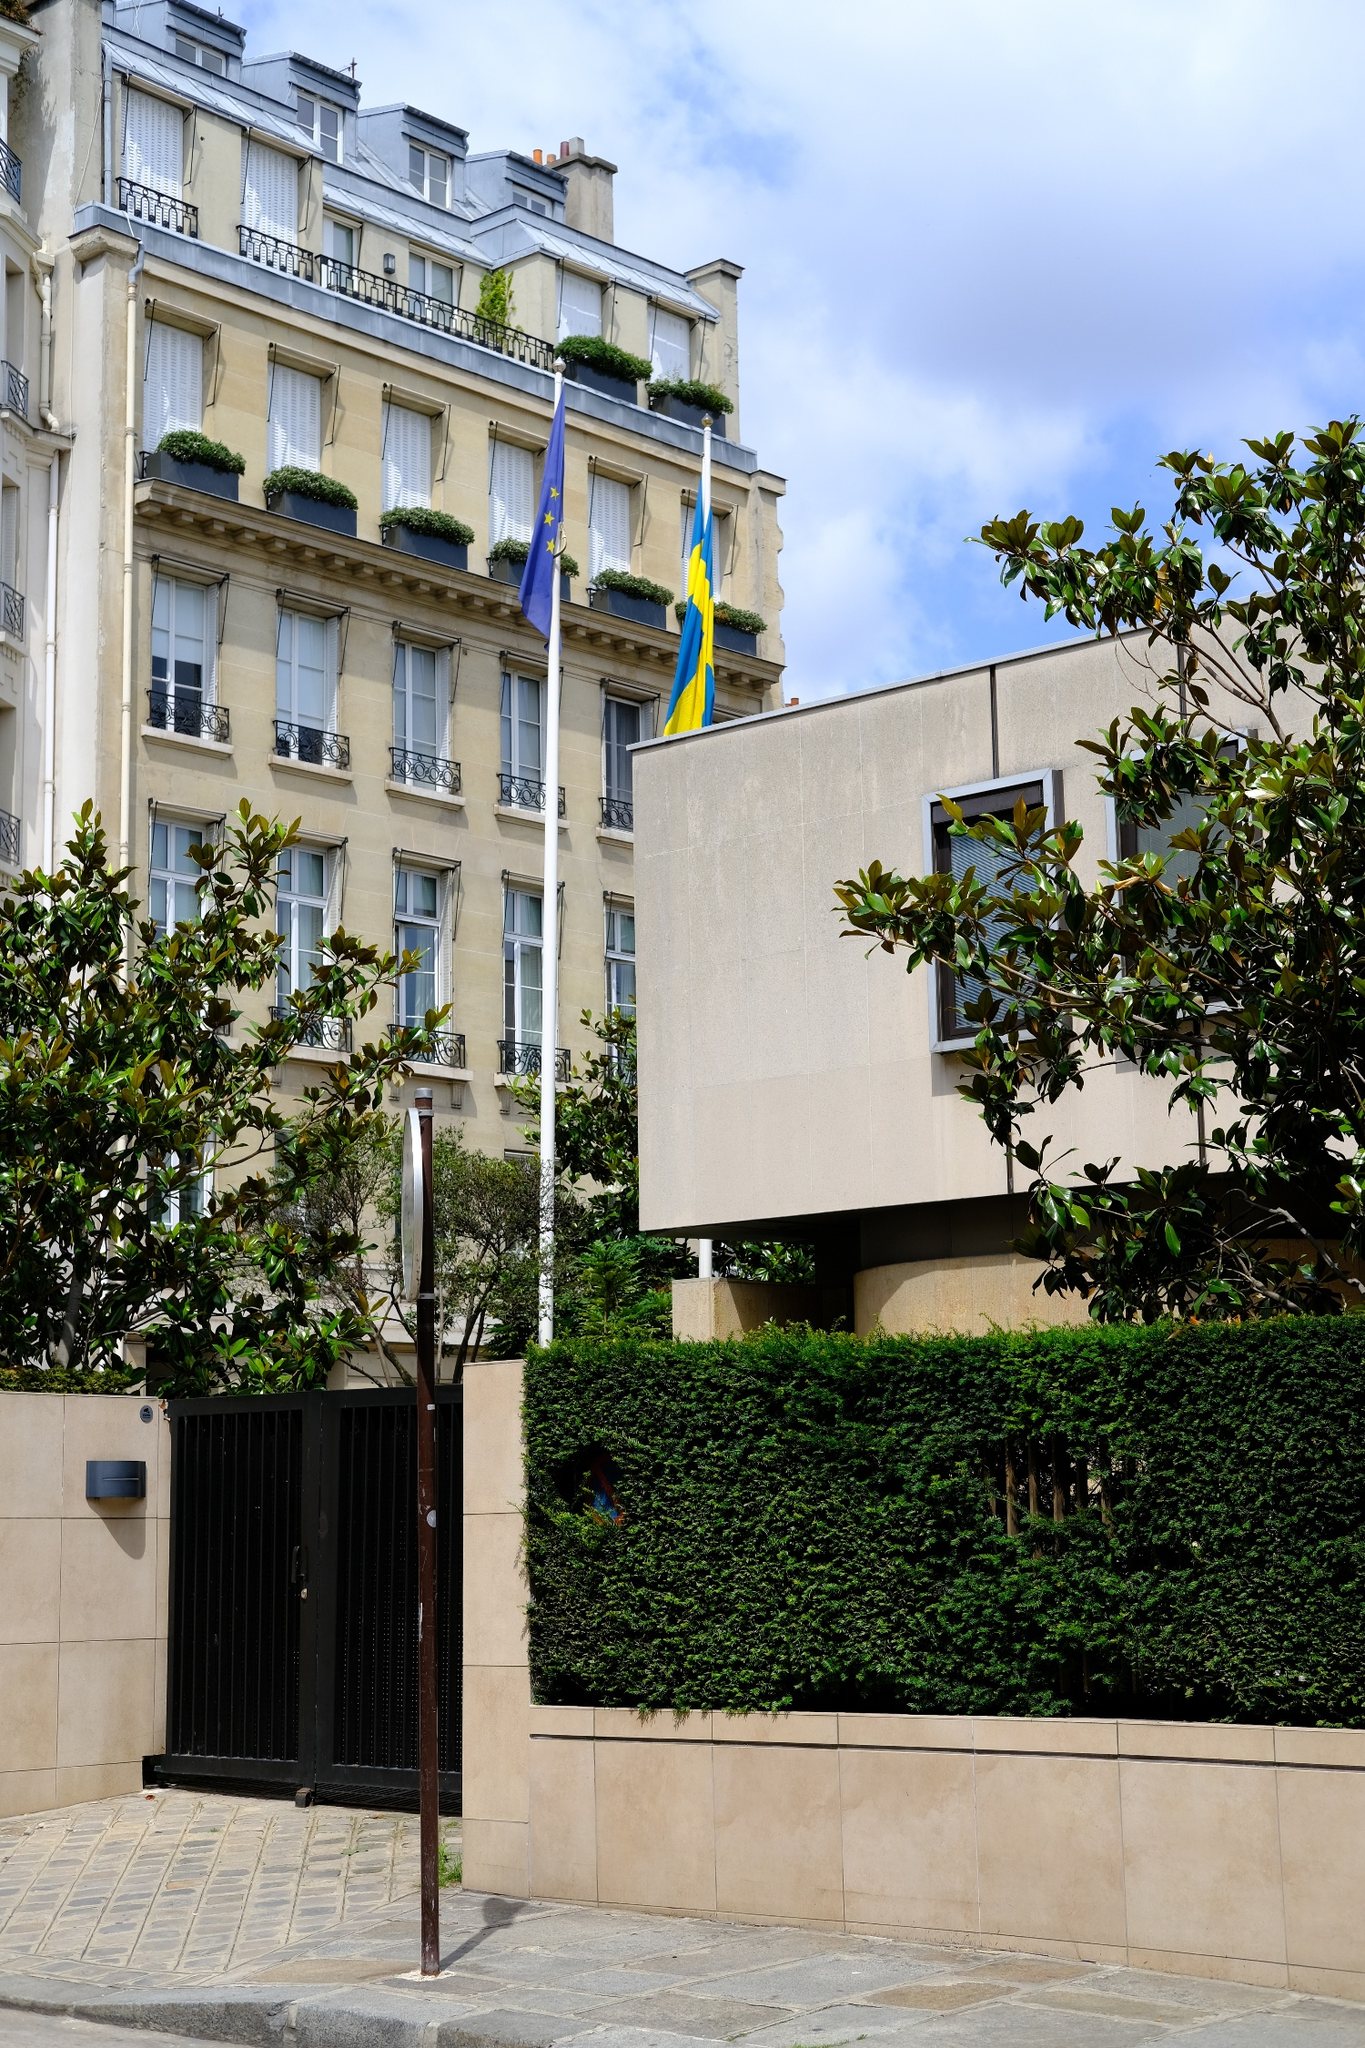Realistically speaking, what function might this building serve given its appearance? Given its elegant architecture and the presence of national flags, this building most likely serves as an embassy or consulate. Embassies are typically housed in visually prominent and well-maintained structures, aligning with the dignified role they play in international relations. The flags signify its diplomatic nature, representing both the European Union and Sweden, which suggests it’s a significant site for Swedish diplomatic missions in France. 